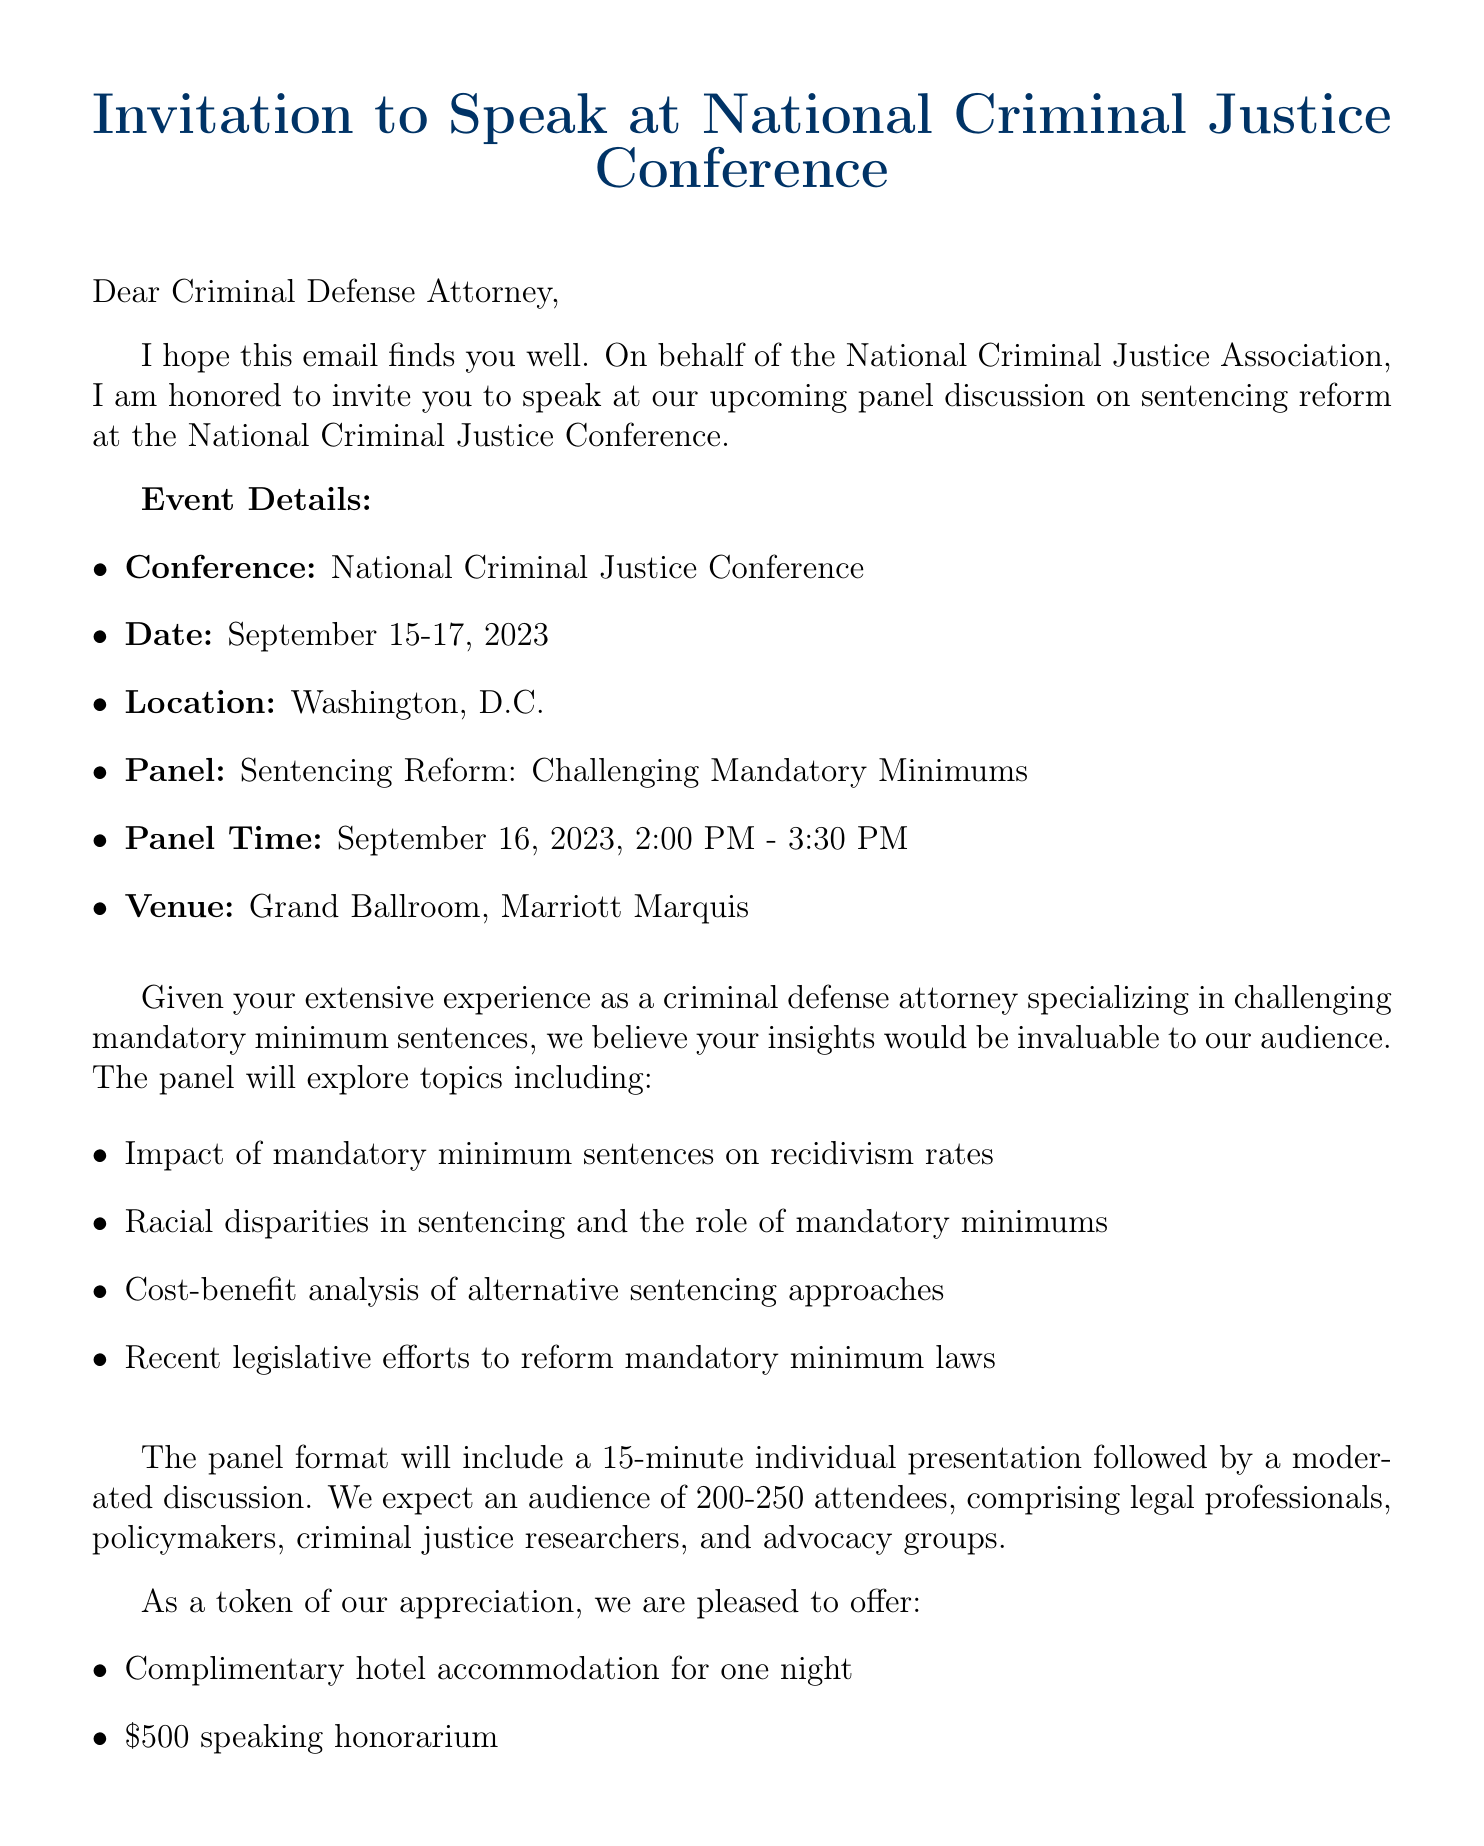What is the date of the National Criminal Justice Conference? The date is provided in the event details section of the document, specifying when the conference will take place.
Answer: September 15-17, 2023 Who is the conference chair? The document lists the organizer's name and title, which indicates who is in charge of the conference.
Answer: Dr. Amanda Chen What is the venue for the panel discussion? The venue is mentioned in the event details, providing the location for the panel discussion within the conference.
Answer: Grand Ballroom, Marriott Marquis How long is the individual presentation during the panel? The document specifies the presentation format, including the duration of the individual presentation.
Answer: 15 minutes What is the speaking honorarium offered to speakers? The logistics section outlines the compensation for speaking, which indicates the honorarium provided.
Answer: $500 What topics will be covered in the panel discussion? The panel topics are provided in a list format, detailing the subjects to be discussed during the panel.
Answer: Impact of mandatory minimum sentences on recidivism rates, Racial disparities in sentencing and the role of mandatory minimums, Cost-benefit analysis of alternative sentencing approaches, Recent legislative efforts to reform mandatory minimum laws What is the expected size of the audience? The audience size is listed in the expected audience section, which gives a range for the number of attendees at the panel.
Answer: 200-250 attendees What type of professionals are expected in the audience? The document outlines the composition of the audience, indicating the variety of attendees at the panel discussion.
Answer: Legal professionals, Policymakers, Criminal justice researchers, Advocacy groups 